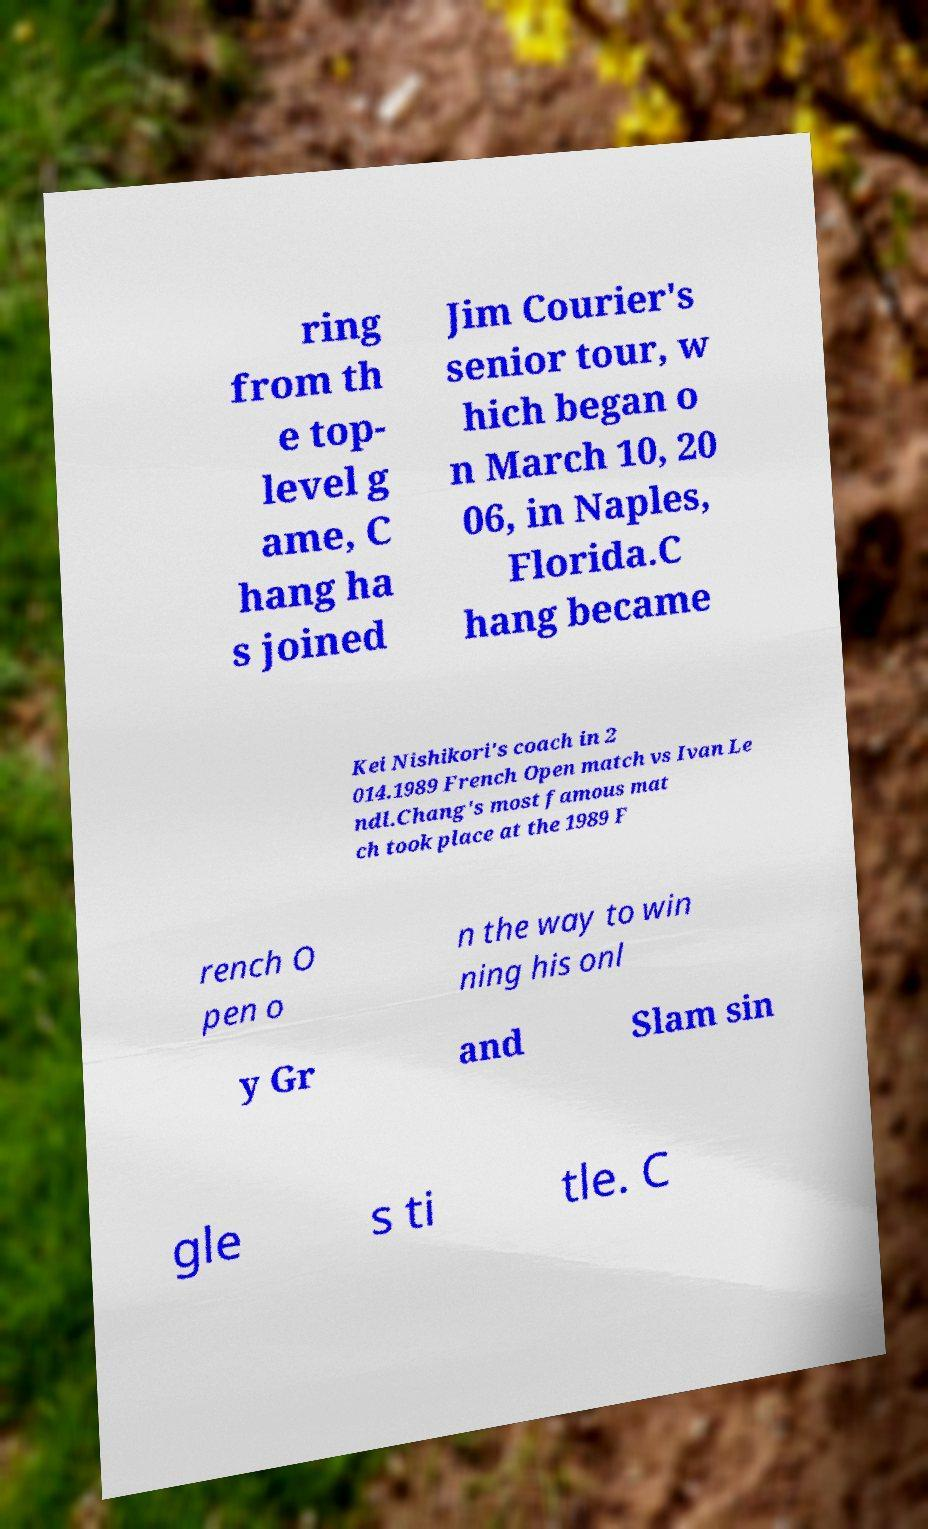I need the written content from this picture converted into text. Can you do that? ring from th e top- level g ame, C hang ha s joined Jim Courier's senior tour, w hich began o n March 10, 20 06, in Naples, Florida.C hang became Kei Nishikori's coach in 2 014.1989 French Open match vs Ivan Le ndl.Chang's most famous mat ch took place at the 1989 F rench O pen o n the way to win ning his onl y Gr and Slam sin gle s ti tle. C 